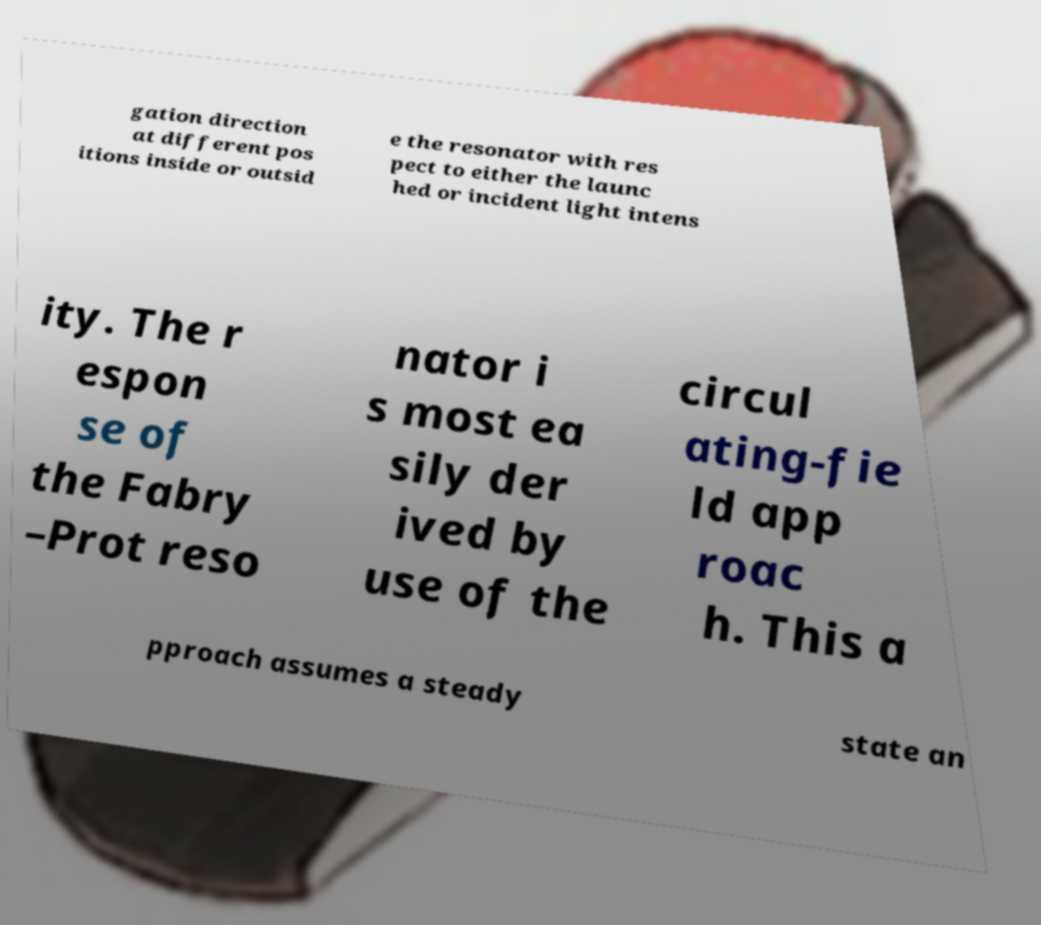What messages or text are displayed in this image? I need them in a readable, typed format. gation direction at different pos itions inside or outsid e the resonator with res pect to either the launc hed or incident light intens ity. The r espon se of the Fabry –Prot reso nator i s most ea sily der ived by use of the circul ating-fie ld app roac h. This a pproach assumes a steady state an 